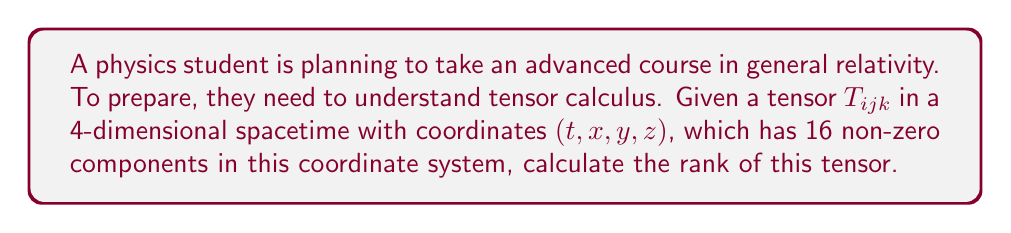Can you solve this math problem? To determine the rank of a tensor, we need to follow these steps:

1) Understand what rank means:
   The rank of a tensor is the number of indices it has.

2) Analyze the given tensor:
   We have $T_{ijk}$, which has three indices.

3) Consider the dimensionality:
   The tensor is defined in a 4-dimensional spacetime.

4) Calculate the maximum possible number of components:
   For a rank-3 tensor in 4-dimensional space, the maximum number of components is:
   $$4^3 = 64$$

5) Compare with given information:
   We're told that there are 16 non-zero components.

6) Conclusion:
   The number of non-zero components doesn't affect the rank. The rank is determined by the number of indices, regardless of how many components are non-zero.

Therefore, the rank of the tensor $T_{ijk}$ is 3.
Answer: 3 